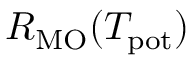Convert formula to latex. <formula><loc_0><loc_0><loc_500><loc_500>R _ { M O } ( T _ { p o t } )</formula> 